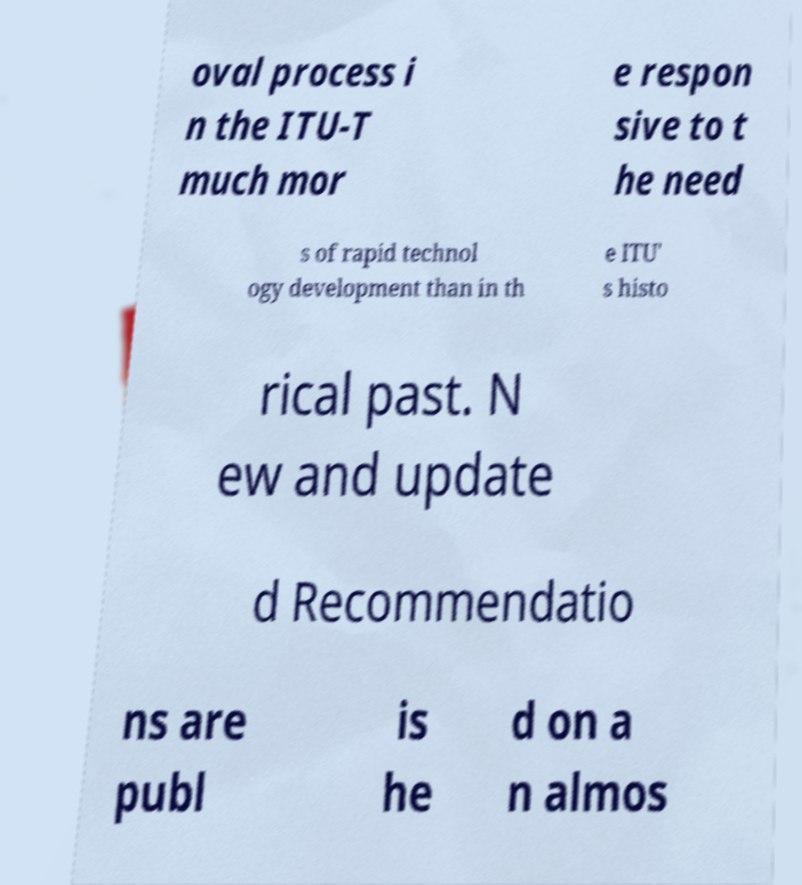I need the written content from this picture converted into text. Can you do that? oval process i n the ITU-T much mor e respon sive to t he need s of rapid technol ogy development than in th e ITU' s histo rical past. N ew and update d Recommendatio ns are publ is he d on a n almos 